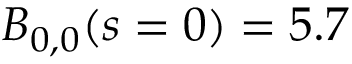<formula> <loc_0><loc_0><loc_500><loc_500>B _ { 0 , 0 } ( s = 0 ) = 5 . 7</formula> 